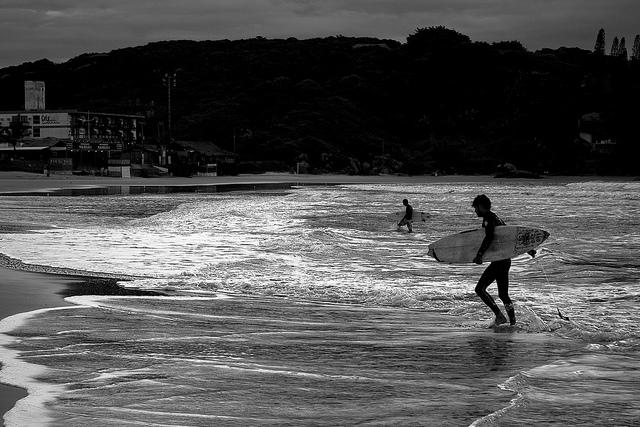What is the problem with this photo? too dark 